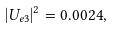<formula> <loc_0><loc_0><loc_500><loc_500>| U _ { e 3 } | ^ { 2 } = 0 . 0 0 2 4 ,</formula> 